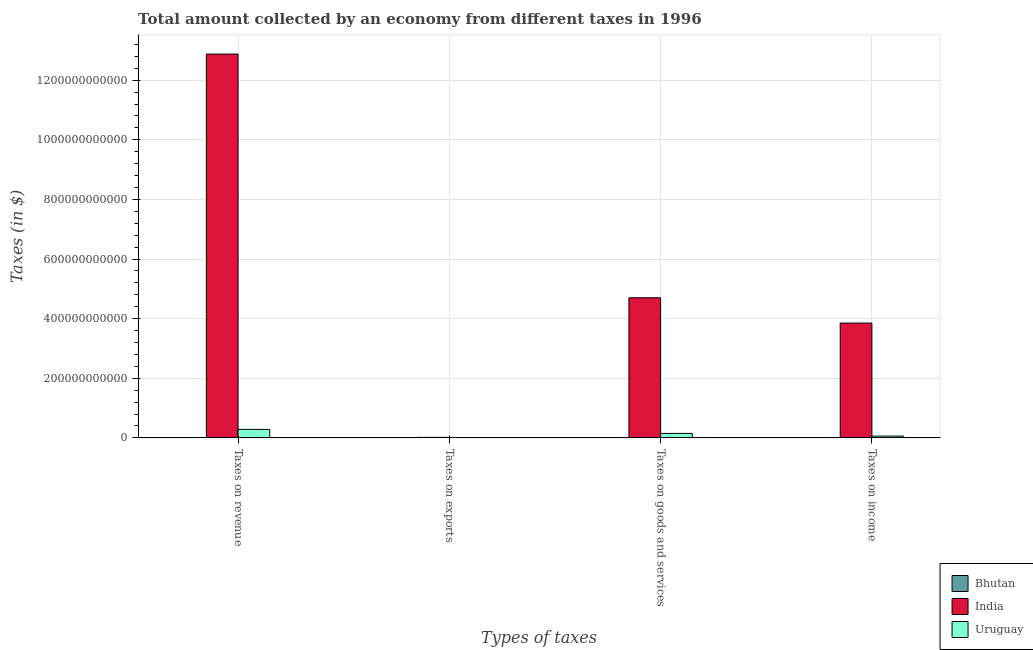How many groups of bars are there?
Give a very brief answer. 4. How many bars are there on the 2nd tick from the left?
Your response must be concise. 3. How many bars are there on the 4th tick from the right?
Make the answer very short. 3. What is the label of the 4th group of bars from the left?
Offer a very short reply. Taxes on income. What is the amount collected as tax on revenue in India?
Give a very brief answer. 1.29e+12. Across all countries, what is the maximum amount collected as tax on goods?
Your answer should be very brief. 4.70e+11. Across all countries, what is the minimum amount collected as tax on exports?
Offer a very short reply. 1.14e+07. In which country was the amount collected as tax on goods minimum?
Your response must be concise. Bhutan. What is the total amount collected as tax on revenue in the graph?
Offer a very short reply. 1.32e+12. What is the difference between the amount collected as tax on revenue in Bhutan and that in India?
Offer a terse response. -1.29e+12. What is the difference between the amount collected as tax on income in India and the amount collected as tax on goods in Uruguay?
Your response must be concise. 3.70e+11. What is the average amount collected as tax on exports per country?
Offer a very short reply. 5.54e+08. What is the difference between the amount collected as tax on revenue and amount collected as tax on income in Bhutan?
Ensure brevity in your answer.  4.18e+08. What is the ratio of the amount collected as tax on revenue in Bhutan to that in India?
Ensure brevity in your answer.  0. Is the amount collected as tax on income in Bhutan less than that in Uruguay?
Your response must be concise. Yes. What is the difference between the highest and the second highest amount collected as tax on exports?
Offer a very short reply. 1.63e+09. What is the difference between the highest and the lowest amount collected as tax on exports?
Your answer should be very brief. 1.63e+09. Is it the case that in every country, the sum of the amount collected as tax on goods and amount collected as tax on revenue is greater than the sum of amount collected as tax on income and amount collected as tax on exports?
Your response must be concise. No. What does the 1st bar from the right in Taxes on goods and services represents?
Your answer should be very brief. Uruguay. How many bars are there?
Ensure brevity in your answer.  12. Are all the bars in the graph horizontal?
Your response must be concise. No. How many countries are there in the graph?
Your response must be concise. 3. What is the difference between two consecutive major ticks on the Y-axis?
Keep it short and to the point. 2.00e+11. Does the graph contain grids?
Offer a very short reply. Yes. How are the legend labels stacked?
Provide a succinct answer. Vertical. What is the title of the graph?
Provide a succinct answer. Total amount collected by an economy from different taxes in 1996. What is the label or title of the X-axis?
Offer a very short reply. Types of taxes. What is the label or title of the Y-axis?
Keep it short and to the point. Taxes (in $). What is the Taxes (in $) in Bhutan in Taxes on revenue?
Provide a short and direct response. 8.44e+08. What is the Taxes (in $) of India in Taxes on revenue?
Offer a terse response. 1.29e+12. What is the Taxes (in $) of Uruguay in Taxes on revenue?
Make the answer very short. 2.84e+1. What is the Taxes (in $) of Bhutan in Taxes on exports?
Your answer should be very brief. 1.14e+07. What is the Taxes (in $) in India in Taxes on exports?
Offer a terse response. 1.64e+09. What is the Taxes (in $) of Bhutan in Taxes on goods and services?
Make the answer very short. 3.82e+08. What is the Taxes (in $) in India in Taxes on goods and services?
Offer a very short reply. 4.70e+11. What is the Taxes (in $) in Uruguay in Taxes on goods and services?
Offer a terse response. 1.49e+1. What is the Taxes (in $) in Bhutan in Taxes on income?
Your answer should be very brief. 4.26e+08. What is the Taxes (in $) of India in Taxes on income?
Provide a succinct answer. 3.85e+11. What is the Taxes (in $) of Uruguay in Taxes on income?
Provide a succinct answer. 5.99e+09. Across all Types of taxes, what is the maximum Taxes (in $) of Bhutan?
Provide a succinct answer. 8.44e+08. Across all Types of taxes, what is the maximum Taxes (in $) of India?
Ensure brevity in your answer.  1.29e+12. Across all Types of taxes, what is the maximum Taxes (in $) in Uruguay?
Your answer should be compact. 2.84e+1. Across all Types of taxes, what is the minimum Taxes (in $) of Bhutan?
Offer a terse response. 1.14e+07. Across all Types of taxes, what is the minimum Taxes (in $) in India?
Provide a succinct answer. 1.64e+09. Across all Types of taxes, what is the minimum Taxes (in $) of Uruguay?
Offer a very short reply. 1.20e+07. What is the total Taxes (in $) of Bhutan in the graph?
Give a very brief answer. 1.66e+09. What is the total Taxes (in $) in India in the graph?
Offer a very short reply. 2.14e+12. What is the total Taxes (in $) in Uruguay in the graph?
Your response must be concise. 4.93e+1. What is the difference between the Taxes (in $) in Bhutan in Taxes on revenue and that in Taxes on exports?
Offer a very short reply. 8.33e+08. What is the difference between the Taxes (in $) in India in Taxes on revenue and that in Taxes on exports?
Your answer should be very brief. 1.29e+12. What is the difference between the Taxes (in $) of Uruguay in Taxes on revenue and that in Taxes on exports?
Provide a short and direct response. 2.84e+1. What is the difference between the Taxes (in $) of Bhutan in Taxes on revenue and that in Taxes on goods and services?
Provide a succinct answer. 4.63e+08. What is the difference between the Taxes (in $) of India in Taxes on revenue and that in Taxes on goods and services?
Give a very brief answer. 8.18e+11. What is the difference between the Taxes (in $) of Uruguay in Taxes on revenue and that in Taxes on goods and services?
Your response must be concise. 1.35e+1. What is the difference between the Taxes (in $) in Bhutan in Taxes on revenue and that in Taxes on income?
Your answer should be compact. 4.18e+08. What is the difference between the Taxes (in $) of India in Taxes on revenue and that in Taxes on income?
Provide a succinct answer. 9.02e+11. What is the difference between the Taxes (in $) of Uruguay in Taxes on revenue and that in Taxes on income?
Provide a succinct answer. 2.24e+1. What is the difference between the Taxes (in $) in Bhutan in Taxes on exports and that in Taxes on goods and services?
Provide a short and direct response. -3.70e+08. What is the difference between the Taxes (in $) in India in Taxes on exports and that in Taxes on goods and services?
Provide a short and direct response. -4.68e+11. What is the difference between the Taxes (in $) in Uruguay in Taxes on exports and that in Taxes on goods and services?
Provide a short and direct response. -1.49e+1. What is the difference between the Taxes (in $) in Bhutan in Taxes on exports and that in Taxes on income?
Offer a very short reply. -4.15e+08. What is the difference between the Taxes (in $) in India in Taxes on exports and that in Taxes on income?
Make the answer very short. -3.83e+11. What is the difference between the Taxes (in $) of Uruguay in Taxes on exports and that in Taxes on income?
Give a very brief answer. -5.98e+09. What is the difference between the Taxes (in $) of Bhutan in Taxes on goods and services and that in Taxes on income?
Make the answer very short. -4.45e+07. What is the difference between the Taxes (in $) in India in Taxes on goods and services and that in Taxes on income?
Provide a short and direct response. 8.49e+1. What is the difference between the Taxes (in $) in Uruguay in Taxes on goods and services and that in Taxes on income?
Offer a very short reply. 8.90e+09. What is the difference between the Taxes (in $) in Bhutan in Taxes on revenue and the Taxes (in $) in India in Taxes on exports?
Provide a succinct answer. -7.96e+08. What is the difference between the Taxes (in $) of Bhutan in Taxes on revenue and the Taxes (in $) of Uruguay in Taxes on exports?
Provide a short and direct response. 8.32e+08. What is the difference between the Taxes (in $) in India in Taxes on revenue and the Taxes (in $) in Uruguay in Taxes on exports?
Ensure brevity in your answer.  1.29e+12. What is the difference between the Taxes (in $) of Bhutan in Taxes on revenue and the Taxes (in $) of India in Taxes on goods and services?
Offer a very short reply. -4.69e+11. What is the difference between the Taxes (in $) of Bhutan in Taxes on revenue and the Taxes (in $) of Uruguay in Taxes on goods and services?
Your response must be concise. -1.40e+1. What is the difference between the Taxes (in $) in India in Taxes on revenue and the Taxes (in $) in Uruguay in Taxes on goods and services?
Keep it short and to the point. 1.27e+12. What is the difference between the Taxes (in $) of Bhutan in Taxes on revenue and the Taxes (in $) of India in Taxes on income?
Your answer should be very brief. -3.84e+11. What is the difference between the Taxes (in $) of Bhutan in Taxes on revenue and the Taxes (in $) of Uruguay in Taxes on income?
Your response must be concise. -5.15e+09. What is the difference between the Taxes (in $) of India in Taxes on revenue and the Taxes (in $) of Uruguay in Taxes on income?
Your response must be concise. 1.28e+12. What is the difference between the Taxes (in $) of Bhutan in Taxes on exports and the Taxes (in $) of India in Taxes on goods and services?
Provide a short and direct response. -4.70e+11. What is the difference between the Taxes (in $) in Bhutan in Taxes on exports and the Taxes (in $) in Uruguay in Taxes on goods and services?
Provide a short and direct response. -1.49e+1. What is the difference between the Taxes (in $) in India in Taxes on exports and the Taxes (in $) in Uruguay in Taxes on goods and services?
Offer a very short reply. -1.32e+1. What is the difference between the Taxes (in $) of Bhutan in Taxes on exports and the Taxes (in $) of India in Taxes on income?
Make the answer very short. -3.85e+11. What is the difference between the Taxes (in $) of Bhutan in Taxes on exports and the Taxes (in $) of Uruguay in Taxes on income?
Ensure brevity in your answer.  -5.98e+09. What is the difference between the Taxes (in $) of India in Taxes on exports and the Taxes (in $) of Uruguay in Taxes on income?
Give a very brief answer. -4.35e+09. What is the difference between the Taxes (in $) of Bhutan in Taxes on goods and services and the Taxes (in $) of India in Taxes on income?
Provide a short and direct response. -3.85e+11. What is the difference between the Taxes (in $) in Bhutan in Taxes on goods and services and the Taxes (in $) in Uruguay in Taxes on income?
Your response must be concise. -5.61e+09. What is the difference between the Taxes (in $) in India in Taxes on goods and services and the Taxes (in $) in Uruguay in Taxes on income?
Give a very brief answer. 4.64e+11. What is the average Taxes (in $) in Bhutan per Types of taxes?
Your answer should be compact. 4.16e+08. What is the average Taxes (in $) of India per Types of taxes?
Your answer should be compact. 5.36e+11. What is the average Taxes (in $) in Uruguay per Types of taxes?
Offer a very short reply. 1.23e+1. What is the difference between the Taxes (in $) of Bhutan and Taxes (in $) of India in Taxes on revenue?
Ensure brevity in your answer.  -1.29e+12. What is the difference between the Taxes (in $) in Bhutan and Taxes (in $) in Uruguay in Taxes on revenue?
Make the answer very short. -2.75e+1. What is the difference between the Taxes (in $) of India and Taxes (in $) of Uruguay in Taxes on revenue?
Make the answer very short. 1.26e+12. What is the difference between the Taxes (in $) of Bhutan and Taxes (in $) of India in Taxes on exports?
Provide a succinct answer. -1.63e+09. What is the difference between the Taxes (in $) of Bhutan and Taxes (in $) of Uruguay in Taxes on exports?
Your answer should be very brief. -6.00e+05. What is the difference between the Taxes (in $) in India and Taxes (in $) in Uruguay in Taxes on exports?
Keep it short and to the point. 1.63e+09. What is the difference between the Taxes (in $) in Bhutan and Taxes (in $) in India in Taxes on goods and services?
Offer a very short reply. -4.70e+11. What is the difference between the Taxes (in $) in Bhutan and Taxes (in $) in Uruguay in Taxes on goods and services?
Provide a succinct answer. -1.45e+1. What is the difference between the Taxes (in $) in India and Taxes (in $) in Uruguay in Taxes on goods and services?
Offer a very short reply. 4.55e+11. What is the difference between the Taxes (in $) of Bhutan and Taxes (in $) of India in Taxes on income?
Make the answer very short. -3.85e+11. What is the difference between the Taxes (in $) in Bhutan and Taxes (in $) in Uruguay in Taxes on income?
Give a very brief answer. -5.56e+09. What is the difference between the Taxes (in $) of India and Taxes (in $) of Uruguay in Taxes on income?
Keep it short and to the point. 3.79e+11. What is the ratio of the Taxes (in $) of Bhutan in Taxes on revenue to that in Taxes on exports?
Provide a succinct answer. 74.05. What is the ratio of the Taxes (in $) of India in Taxes on revenue to that in Taxes on exports?
Offer a terse response. 785.13. What is the ratio of the Taxes (in $) of Uruguay in Taxes on revenue to that in Taxes on exports?
Your response must be concise. 2364.75. What is the ratio of the Taxes (in $) of Bhutan in Taxes on revenue to that in Taxes on goods and services?
Your response must be concise. 2.21. What is the ratio of the Taxes (in $) in India in Taxes on revenue to that in Taxes on goods and services?
Offer a terse response. 2.74. What is the ratio of the Taxes (in $) of Uruguay in Taxes on revenue to that in Taxes on goods and services?
Your answer should be very brief. 1.91. What is the ratio of the Taxes (in $) of Bhutan in Taxes on revenue to that in Taxes on income?
Ensure brevity in your answer.  1.98. What is the ratio of the Taxes (in $) in India in Taxes on revenue to that in Taxes on income?
Keep it short and to the point. 3.34. What is the ratio of the Taxes (in $) in Uruguay in Taxes on revenue to that in Taxes on income?
Your answer should be compact. 4.74. What is the ratio of the Taxes (in $) of Bhutan in Taxes on exports to that in Taxes on goods and services?
Provide a short and direct response. 0.03. What is the ratio of the Taxes (in $) of India in Taxes on exports to that in Taxes on goods and services?
Provide a short and direct response. 0. What is the ratio of the Taxes (in $) in Uruguay in Taxes on exports to that in Taxes on goods and services?
Give a very brief answer. 0. What is the ratio of the Taxes (in $) of Bhutan in Taxes on exports to that in Taxes on income?
Your answer should be very brief. 0.03. What is the ratio of the Taxes (in $) in India in Taxes on exports to that in Taxes on income?
Your answer should be very brief. 0. What is the ratio of the Taxes (in $) of Uruguay in Taxes on exports to that in Taxes on income?
Offer a very short reply. 0. What is the ratio of the Taxes (in $) in Bhutan in Taxes on goods and services to that in Taxes on income?
Your response must be concise. 0.9. What is the ratio of the Taxes (in $) of India in Taxes on goods and services to that in Taxes on income?
Keep it short and to the point. 1.22. What is the ratio of the Taxes (in $) of Uruguay in Taxes on goods and services to that in Taxes on income?
Offer a very short reply. 2.49. What is the difference between the highest and the second highest Taxes (in $) in Bhutan?
Offer a very short reply. 4.18e+08. What is the difference between the highest and the second highest Taxes (in $) in India?
Your answer should be compact. 8.18e+11. What is the difference between the highest and the second highest Taxes (in $) of Uruguay?
Offer a very short reply. 1.35e+1. What is the difference between the highest and the lowest Taxes (in $) in Bhutan?
Offer a terse response. 8.33e+08. What is the difference between the highest and the lowest Taxes (in $) of India?
Provide a succinct answer. 1.29e+12. What is the difference between the highest and the lowest Taxes (in $) in Uruguay?
Make the answer very short. 2.84e+1. 